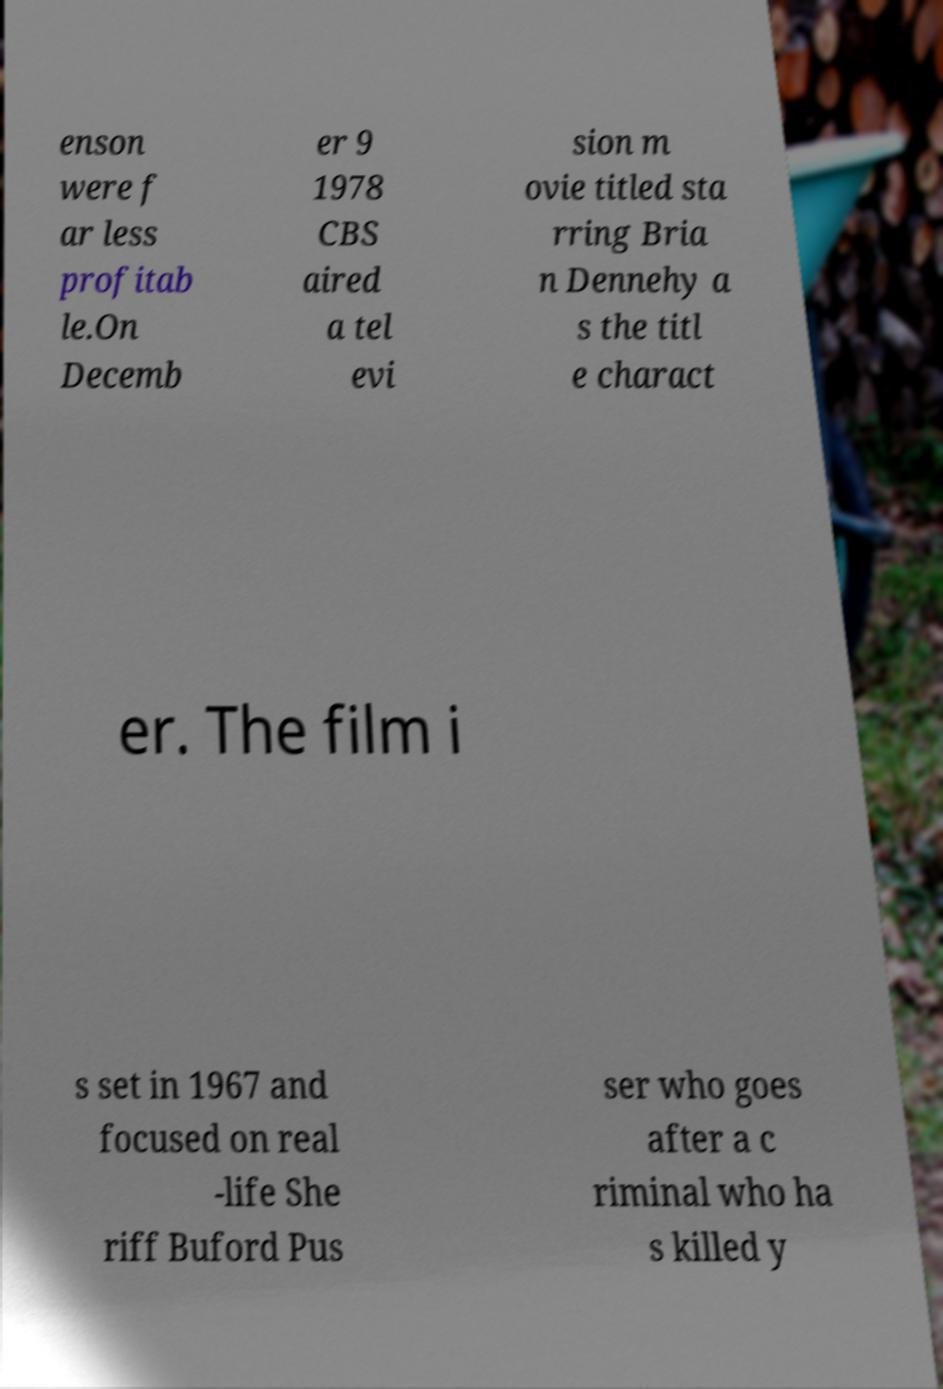Could you extract and type out the text from this image? enson were f ar less profitab le.On Decemb er 9 1978 CBS aired a tel evi sion m ovie titled sta rring Bria n Dennehy a s the titl e charact er. The film i s set in 1967 and focused on real -life She riff Buford Pus ser who goes after a c riminal who ha s killed y 